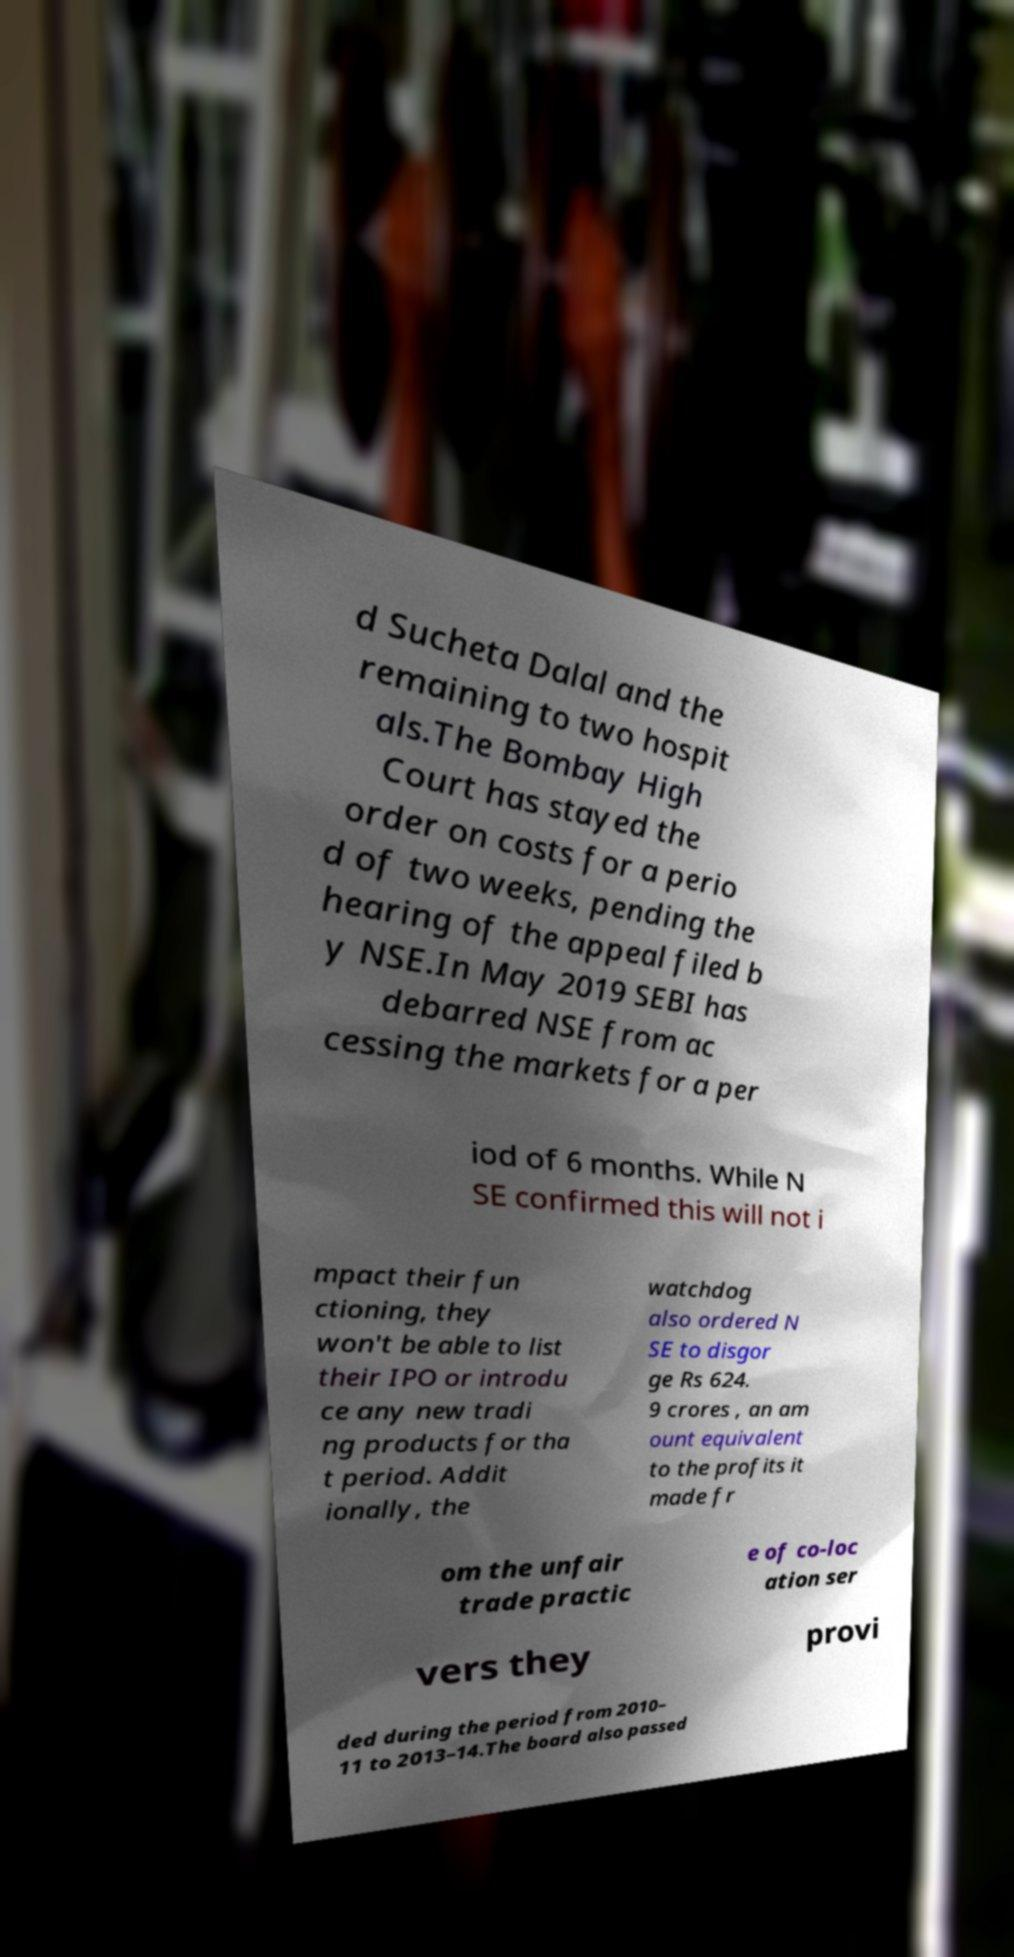What messages or text are displayed in this image? I need them in a readable, typed format. d Sucheta Dalal and the remaining to two hospit als.The Bombay High Court has stayed the order on costs for a perio d of two weeks, pending the hearing of the appeal filed b y NSE.In May 2019 SEBI has debarred NSE from ac cessing the markets for a per iod of 6 months. While N SE confirmed this will not i mpact their fun ctioning, they won't be able to list their IPO or introdu ce any new tradi ng products for tha t period. Addit ionally, the watchdog also ordered N SE to disgor ge Rs 624. 9 crores , an am ount equivalent to the profits it made fr om the unfair trade practic e of co-loc ation ser vers they provi ded during the period from 2010– 11 to 2013–14.The board also passed 